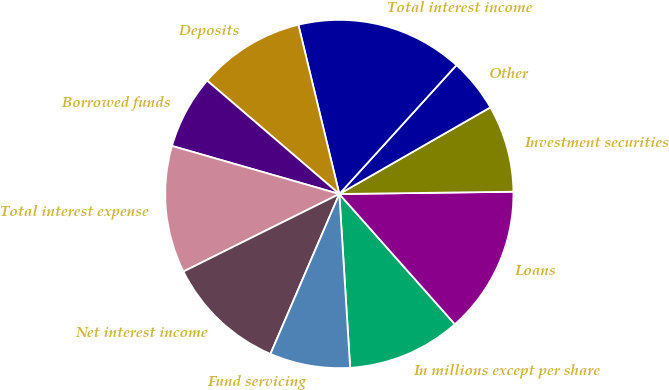Convert chart to OTSL. <chart><loc_0><loc_0><loc_500><loc_500><pie_chart><fcel>In millions except per share<fcel>Loans<fcel>Investment securities<fcel>Other<fcel>Total interest income<fcel>Deposits<fcel>Borrowed funds<fcel>Total interest expense<fcel>Net interest income<fcel>Fund servicing<nl><fcel>10.56%<fcel>13.66%<fcel>8.08%<fcel>4.97%<fcel>15.52%<fcel>9.94%<fcel>6.83%<fcel>11.8%<fcel>11.18%<fcel>7.46%<nl></chart> 